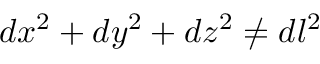Convert formula to latex. <formula><loc_0><loc_0><loc_500><loc_500>d x ^ { 2 } + d y ^ { 2 } + d z ^ { 2 } \neq d l ^ { 2 }</formula> 